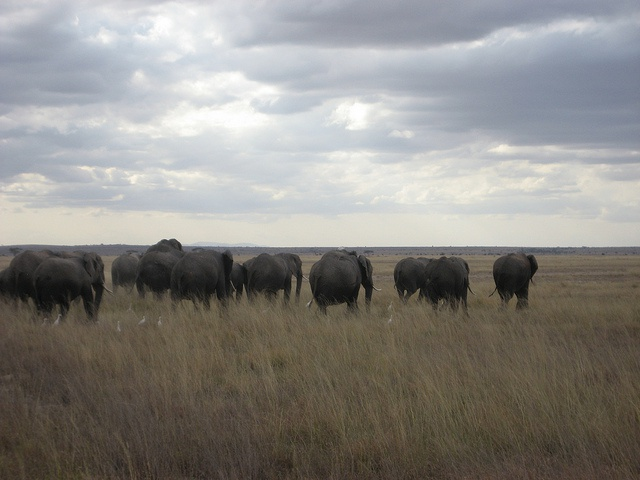Describe the objects in this image and their specific colors. I can see elephant in lightgray, black, and gray tones, elephant in lightgray, black, and gray tones, elephant in lightgray, black, and gray tones, elephant in lightgray, black, and gray tones, and elephant in lightgray, black, and gray tones in this image. 